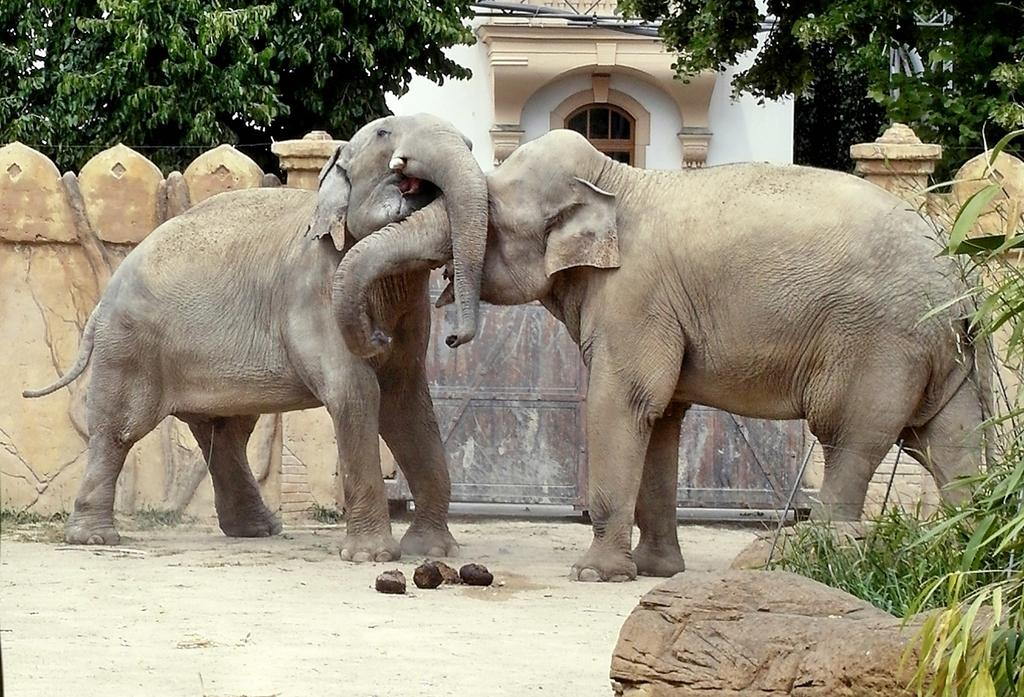How many elephants are present in the image? There are two elephants in the image. What type of vegetation can be seen in the image? There is grass in the image. What architectural feature is present in the image? There is a gate in the image. What is the background of the image composed of? There is a wall and trees in the background of the image. What type of structure is visible in the background? There is a building in the background of the image. What type of frogs can be seen driving a car in the image? There are no frogs or cars present in the image; it features two elephants, grass, a gate, a wall, trees, and a building. 